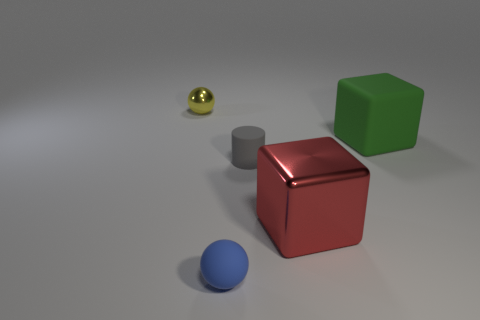Add 4 small cyan metallic cylinders. How many objects exist? 9 Subtract all cubes. How many objects are left? 3 Add 5 big objects. How many big objects are left? 7 Add 2 red rubber things. How many red rubber things exist? 2 Subtract 0 cyan cubes. How many objects are left? 5 Subtract all green cubes. Subtract all small gray rubber cylinders. How many objects are left? 3 